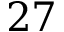Convert formula to latex. <formula><loc_0><loc_0><loc_500><loc_500>2 7</formula> 